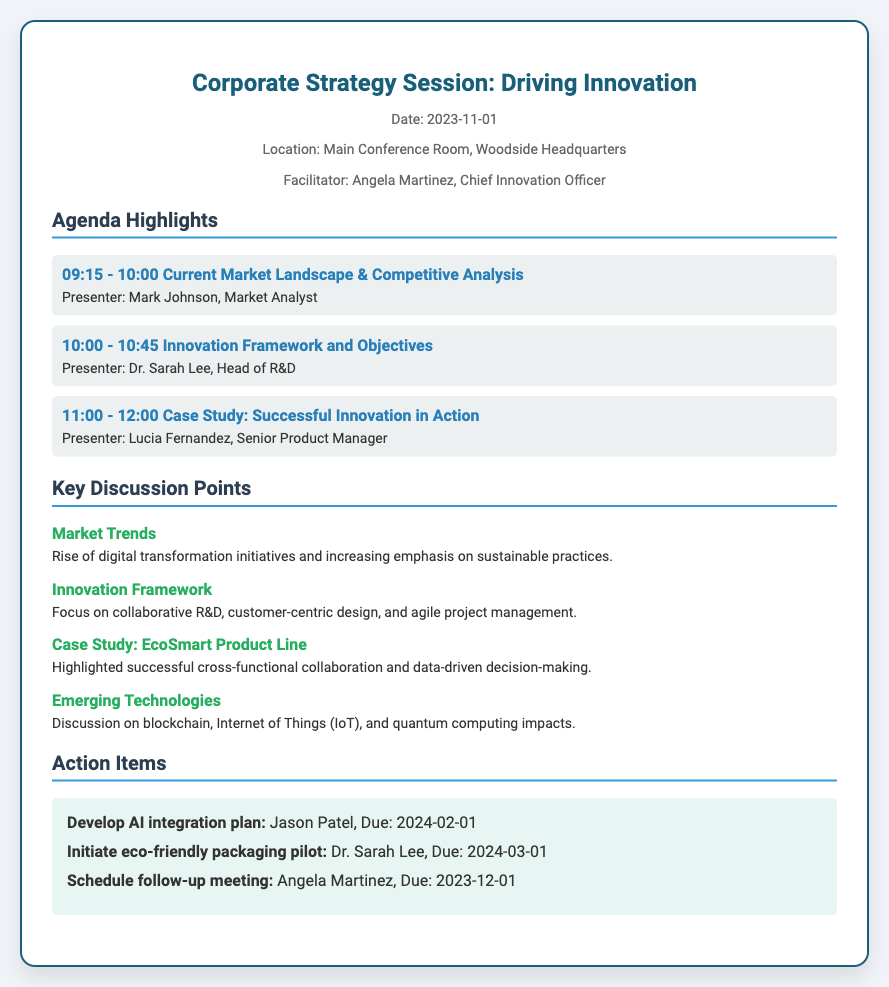What is the date of the Corporate Strategy Session? The date of the session is mentioned in the header of the document.
Answer: 2023-11-01 Who facilitated the meeting? The facilitator's name is stated in the header section under "Facilitator."
Answer: Angela Martinez What is one of the key discussion points mentioned? The discussion points can be found under the "Key Discussion Points" section of the document.
Answer: Market Trends Who presented the innovation framework and objectives? The individual's name and title are provided in the agenda section for that time slot.
Answer: Dr. Sarah Lee What is the due date for the action item related to AI integration plan? The due date for this action item is specified in the "Action Items" section.
Answer: 2024-02-01 What is the main focus of the innovation framework discussed? The key focus areas are outlined in the minutes section regarding innovation.
Answer: Collaborative R&D What type of product line was highlighted in the case study? The specific product line mentioned is noted in the key discussion points of the document.
Answer: EcoSmart Product Line What time does the session start? The starting time is noted in the agenda highlights section.
Answer: 09:15 Who is the Senior Product Manager presenting the case study? The individual's title and name are indicated in the agenda section for the case study.
Answer: Lucia Fernandez 